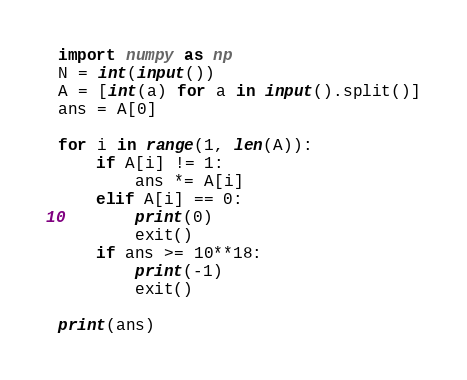Convert code to text. <code><loc_0><loc_0><loc_500><loc_500><_Python_>import numpy as np
N = int(input())
A = [int(a) for a in input().split()]
ans = A[0]

for i in range(1, len(A)):
    if A[i] != 1:
        ans *= A[i]
    elif A[i] == 0:
        print(0)
        exit()
    if ans >= 10**18:
        print(-1)
        exit()

print(ans)</code> 